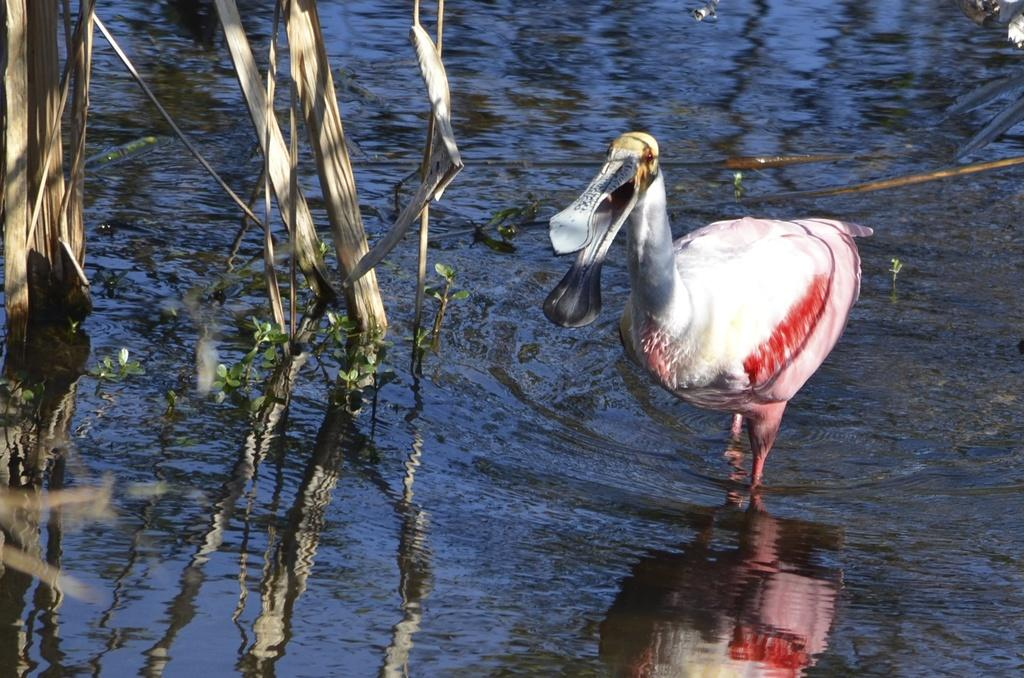What is the primary element in the image? The image consists of water. What can be seen in the water? There is a crane in the water. What is the color of the crane? The crane is white in color. What else is present in the middle of the image? There are plants in the middle of the image. How does the crane use glue to stick to the water in the image? The crane does not use glue to stick to the water in the image; it is a living creature that can float and swim in the water. 